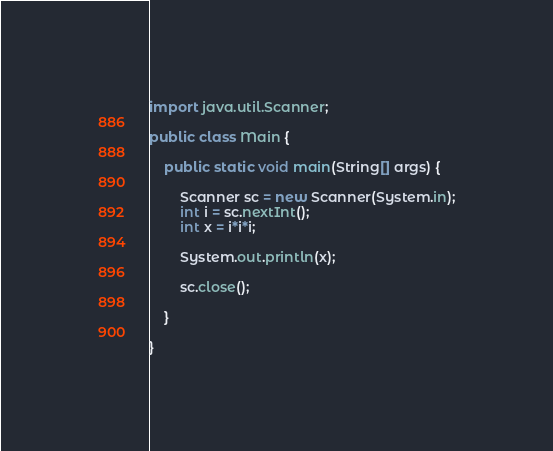Convert code to text. <code><loc_0><loc_0><loc_500><loc_500><_Java_>import java.util.Scanner;

public class Main {

	public static void main(String[] args) {
		
		Scanner sc = new Scanner(System.in);
		int i = sc.nextInt();
	    int x = i*i*i;
	     
	    System.out.println(x);
	     
	    sc.close();

	}

}</code> 